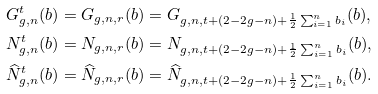<formula> <loc_0><loc_0><loc_500><loc_500>G _ { g , n } ^ { t } ( { b } ) & = G _ { g , n , r } ( { b } ) = G _ { g , n , t + ( 2 - 2 g - n ) + \frac { 1 } { 2 } \sum _ { i = 1 } ^ { n } b _ { i } } ( { b } ) , \\ N _ { g , n } ^ { t } ( { b } ) & = N _ { g , n , r } ( { b } ) = N _ { g , n , t + ( 2 - 2 g - n ) + \frac { 1 } { 2 } \sum _ { i = 1 } ^ { n } b _ { i } } ( { b } ) , \\ \widehat { N } _ { g , n } ^ { t } ( { b } ) & = \widehat { N } _ { g , n , r } ( { b } ) = \widehat { N } _ { g , n , t + ( 2 - 2 g - n ) + \frac { 1 } { 2 } \sum _ { i = 1 } ^ { n } b _ { i } } ( { b } ) .</formula> 